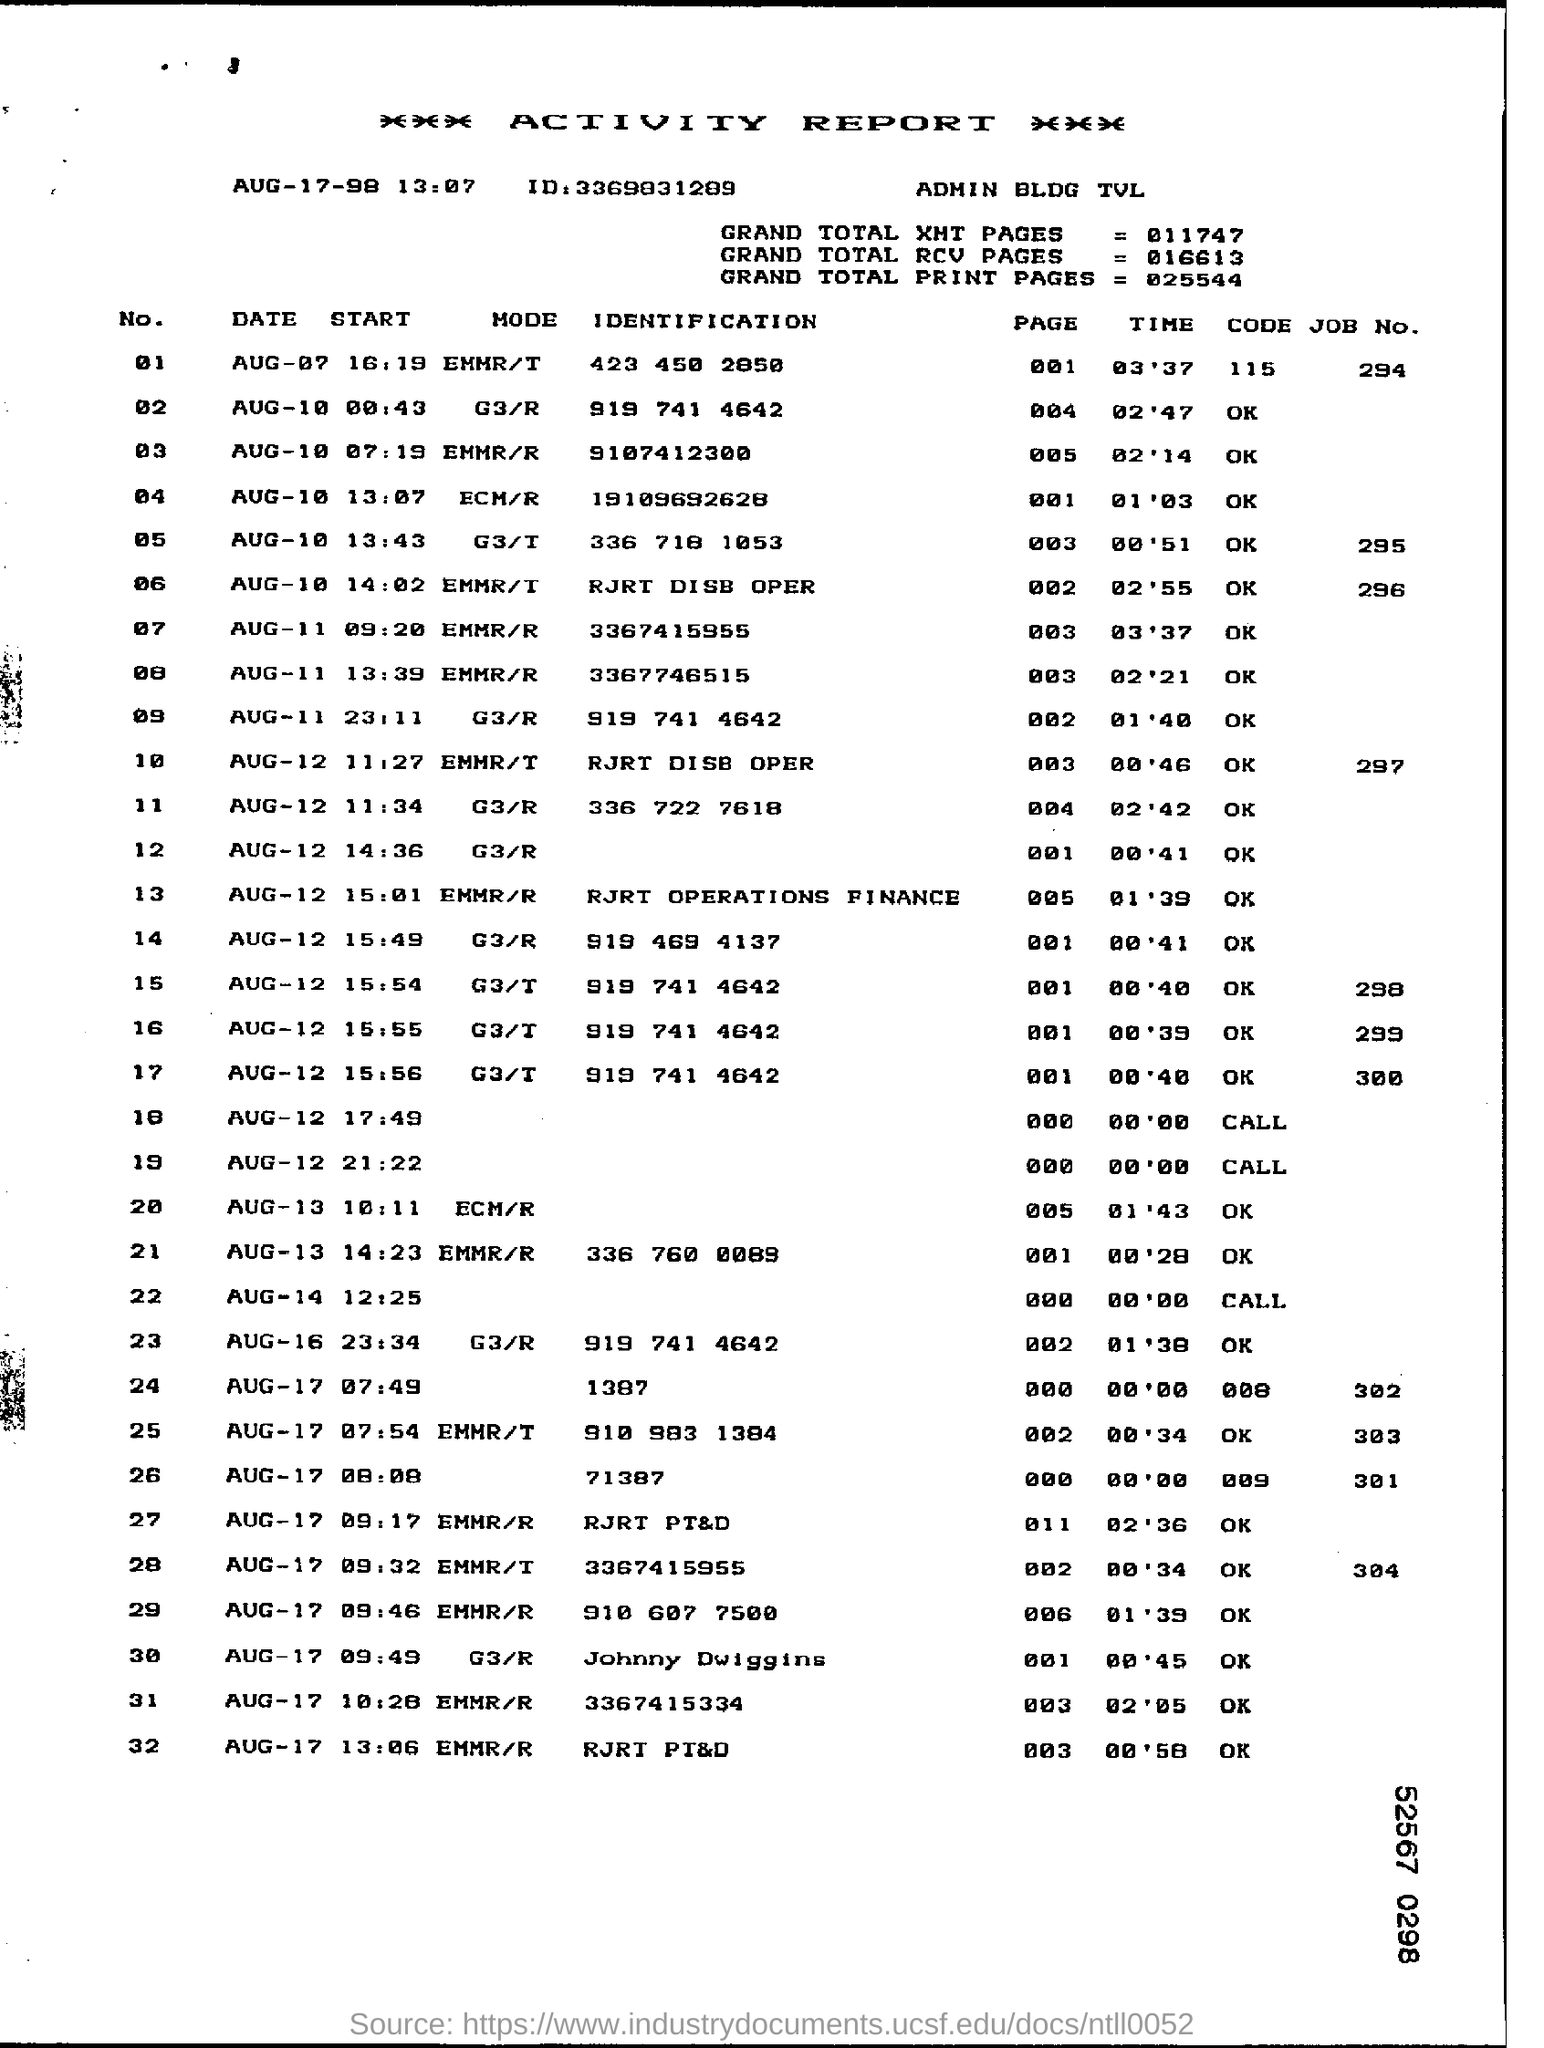Give some essential details in this illustration. What is the meaning of the symbol 'Mode' appearing next to the number '01'? EMER/T.. The value of the 'Grand Total RCV Pages' is 016613... The ID mentioned under the 'Activity Report' heading is 3369831289. 